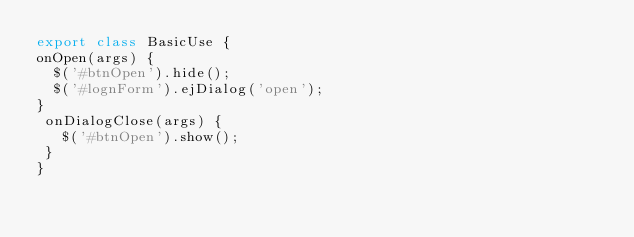<code> <loc_0><loc_0><loc_500><loc_500><_JavaScript_>export class BasicUse {
onOpen(args) {
  $('#btnOpen').hide();
  $('#lognForm').ejDialog('open');
}
 onDialogClose(args) {
   $('#btnOpen').show();
 }
}
</code> 